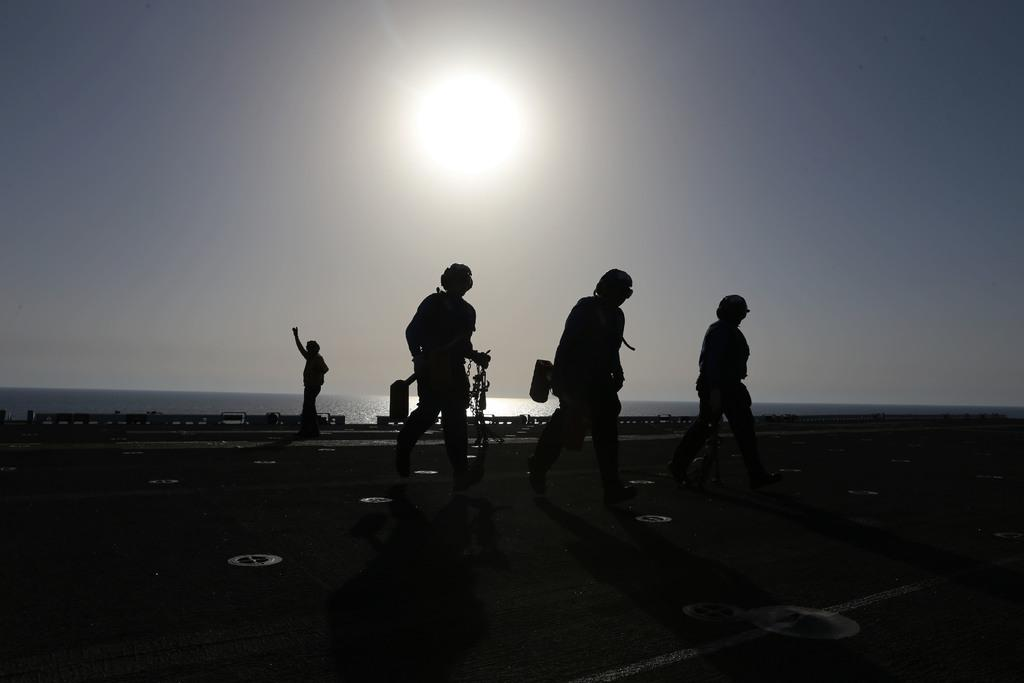How many people are in the foreground of the image? There are four men in the foreground of the image. What are the men doing in the image? The men are walking on the road. What can be seen in the background of the image? Water and the sky are visible in the background of the image. Can the sun be seen in the image? Yes, the sun is observable in the sky. What type of connection can be seen between the men's fingers in the image? There is no mention of fingers or any connection between them in the image. 